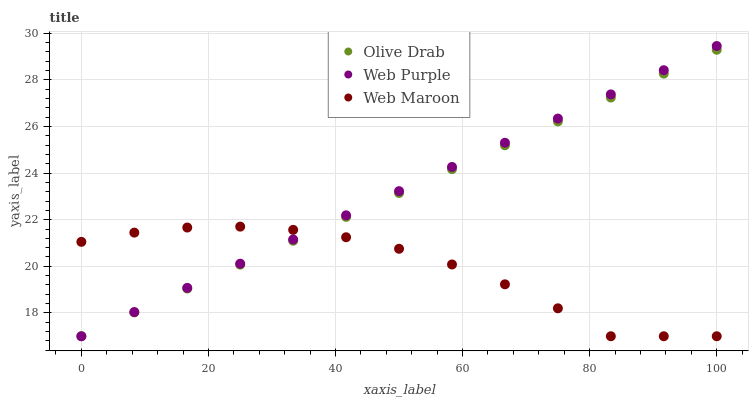Does Web Maroon have the minimum area under the curve?
Answer yes or no. Yes. Does Web Purple have the maximum area under the curve?
Answer yes or no. Yes. Does Olive Drab have the minimum area under the curve?
Answer yes or no. No. Does Olive Drab have the maximum area under the curve?
Answer yes or no. No. Is Web Purple the smoothest?
Answer yes or no. Yes. Is Web Maroon the roughest?
Answer yes or no. Yes. Is Olive Drab the smoothest?
Answer yes or no. No. Is Olive Drab the roughest?
Answer yes or no. No. Does Web Purple have the lowest value?
Answer yes or no. Yes. Does Web Purple have the highest value?
Answer yes or no. Yes. Does Olive Drab have the highest value?
Answer yes or no. No. Does Web Maroon intersect Web Purple?
Answer yes or no. Yes. Is Web Maroon less than Web Purple?
Answer yes or no. No. Is Web Maroon greater than Web Purple?
Answer yes or no. No. 